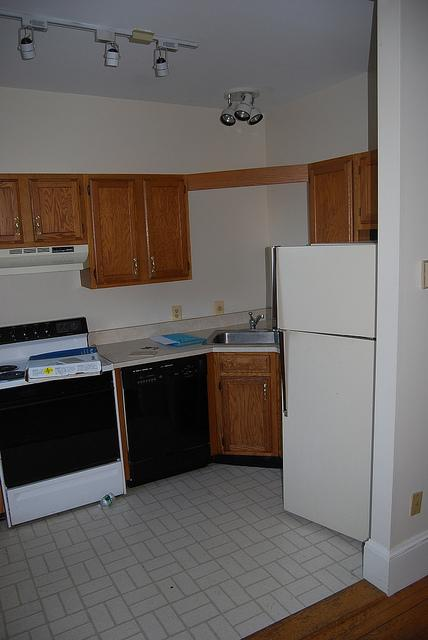What kind of cable is used in the lower right socket? coax 